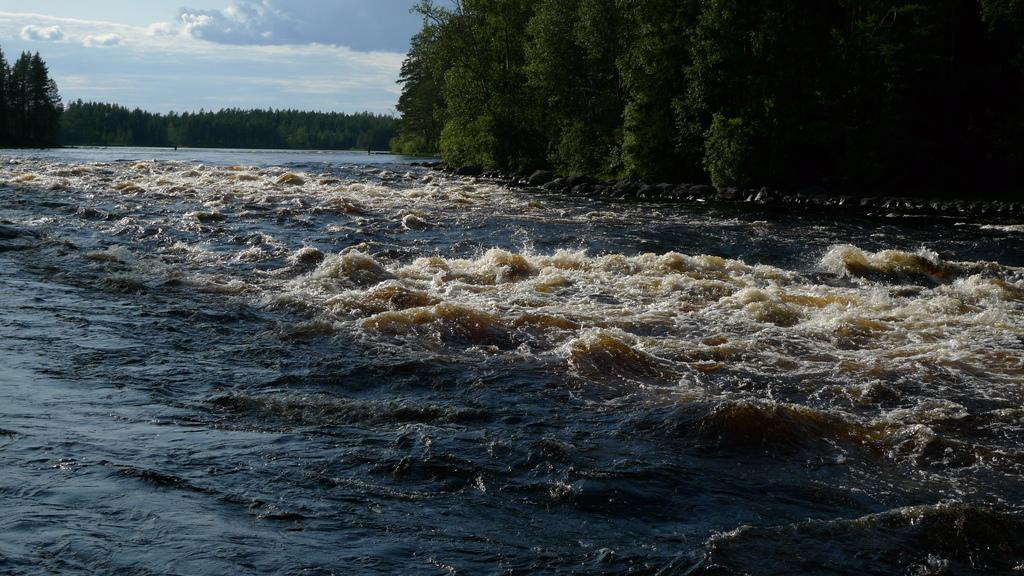Can you describe this image briefly? In this image, we can see a river in between trees. There is a sky in the top left of the image. 